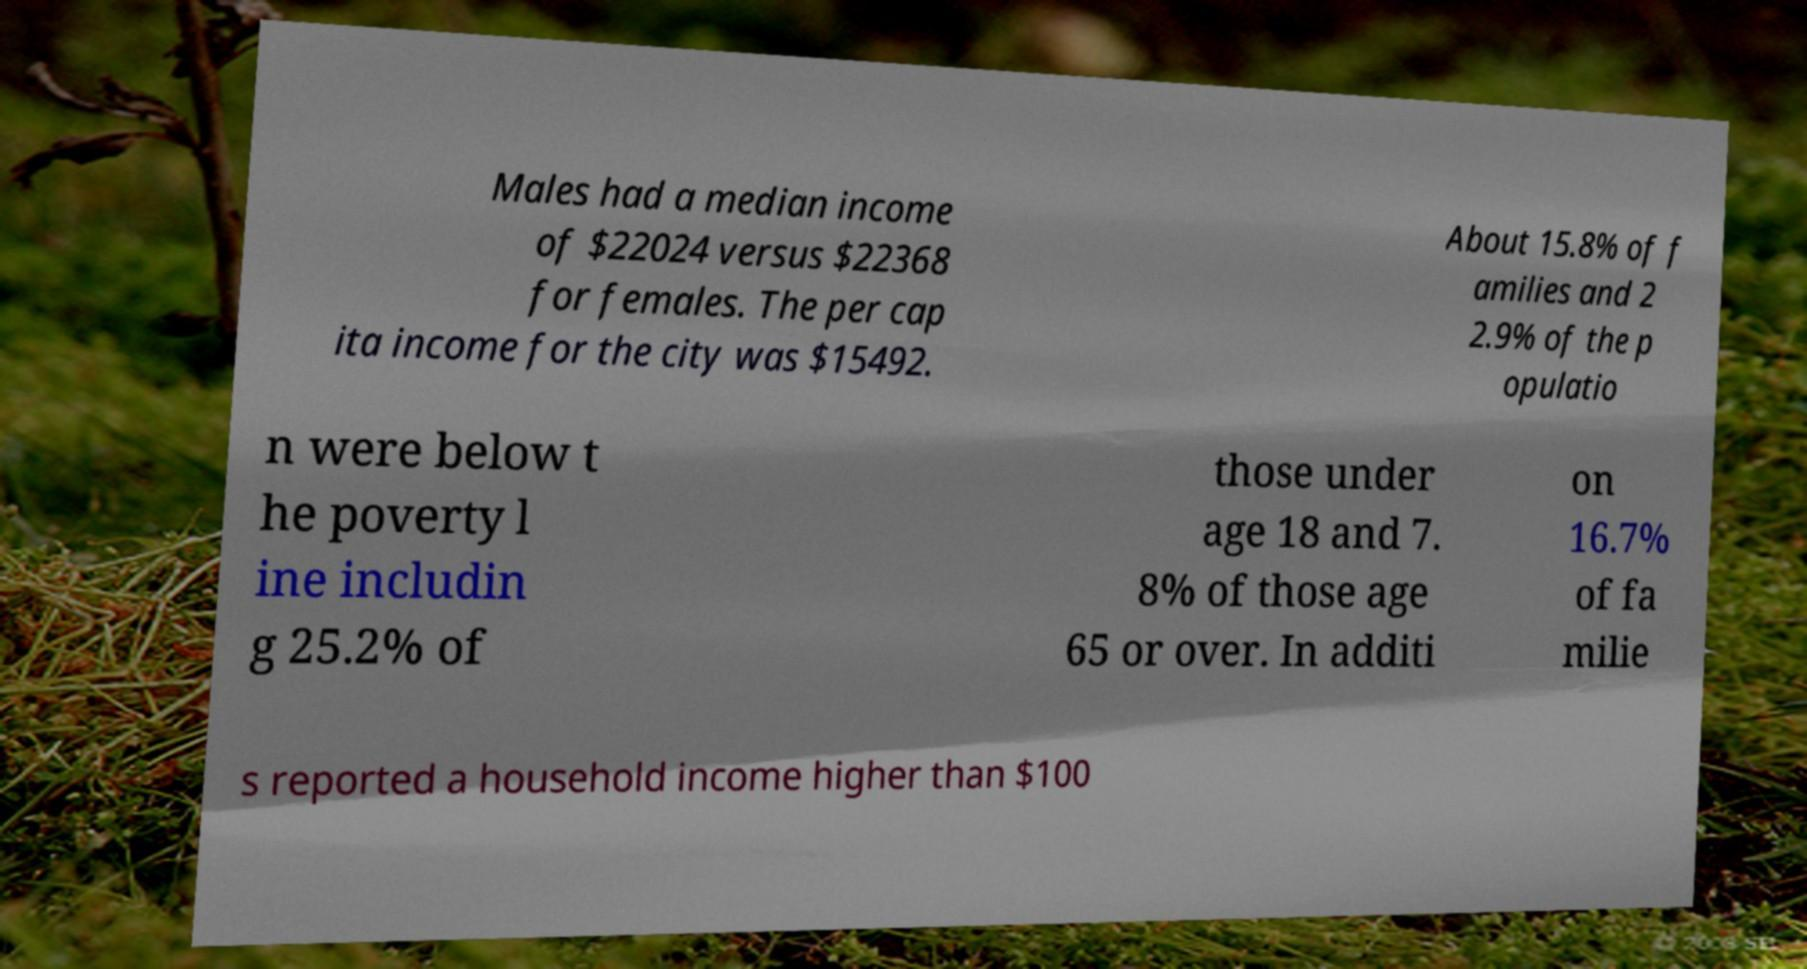What messages or text are displayed in this image? I need them in a readable, typed format. Males had a median income of $22024 versus $22368 for females. The per cap ita income for the city was $15492. About 15.8% of f amilies and 2 2.9% of the p opulatio n were below t he poverty l ine includin g 25.2% of those under age 18 and 7. 8% of those age 65 or over. In additi on 16.7% of fa milie s reported a household income higher than $100 